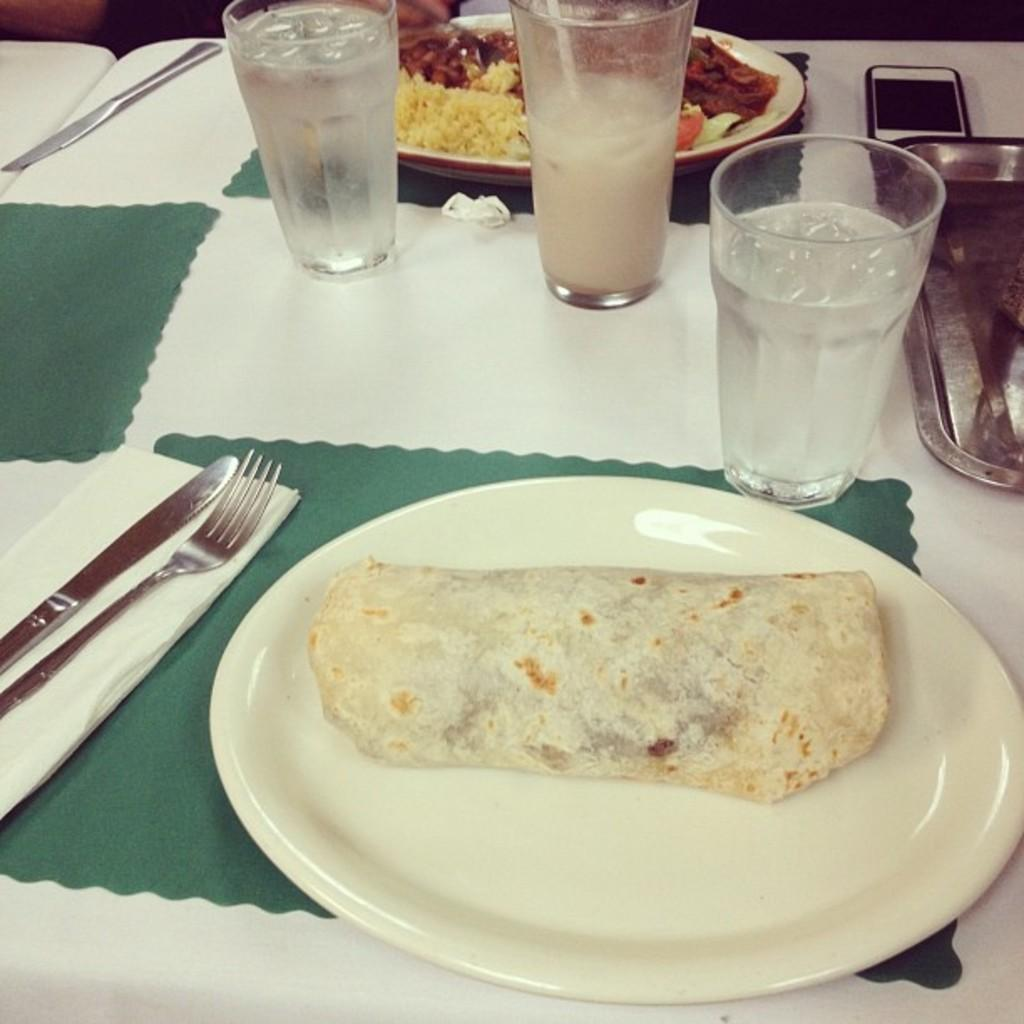What type of furniture is present in the image? There is a table in the image. What utensils can be seen on the table? Knives and forks are on the table. What items are used to cover the table surface? Mats are on the table. What type of dishware is present on the table? There are glasses and plates with food items on the table. What decorative item is on the table? There is a mobile on the table. What type of paper product is on the table? Tissue papers are on the table. What type of container is on the table? There is a tray on the table. What type of breakfast is being served on the table in the image? There is no indication of breakfast being served in the image; it only shows a table with various items on it. Can you see a duck in the image? There is no duck present in the image. 